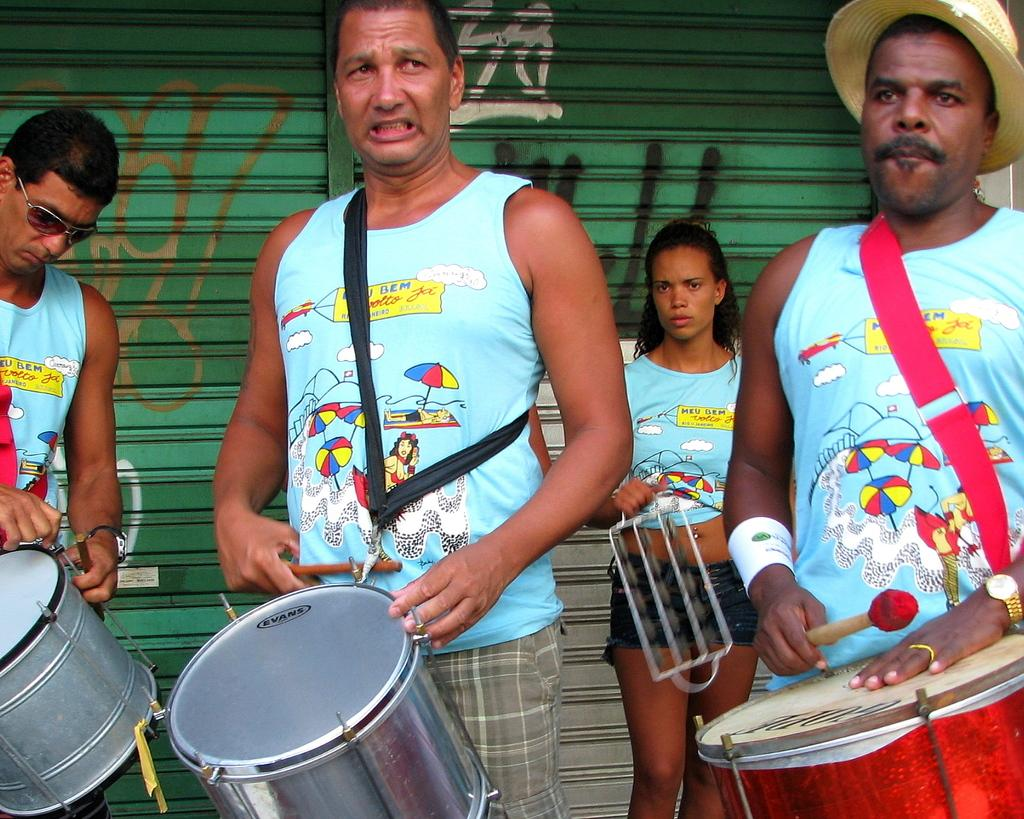How many people are in the image? There are four people in the image. What are the people in the image doing? The four people are standing. What are the people wearing? The four people are wearing the same dress. What are the people holding in the image? The four people are holding musical instruments. What type of eye is visible on the musical instruments in the image? There are no eyes visible on the musical instruments in the image. What event is taking place in the image? The provided facts do not mention any specific event taking place in the image. 